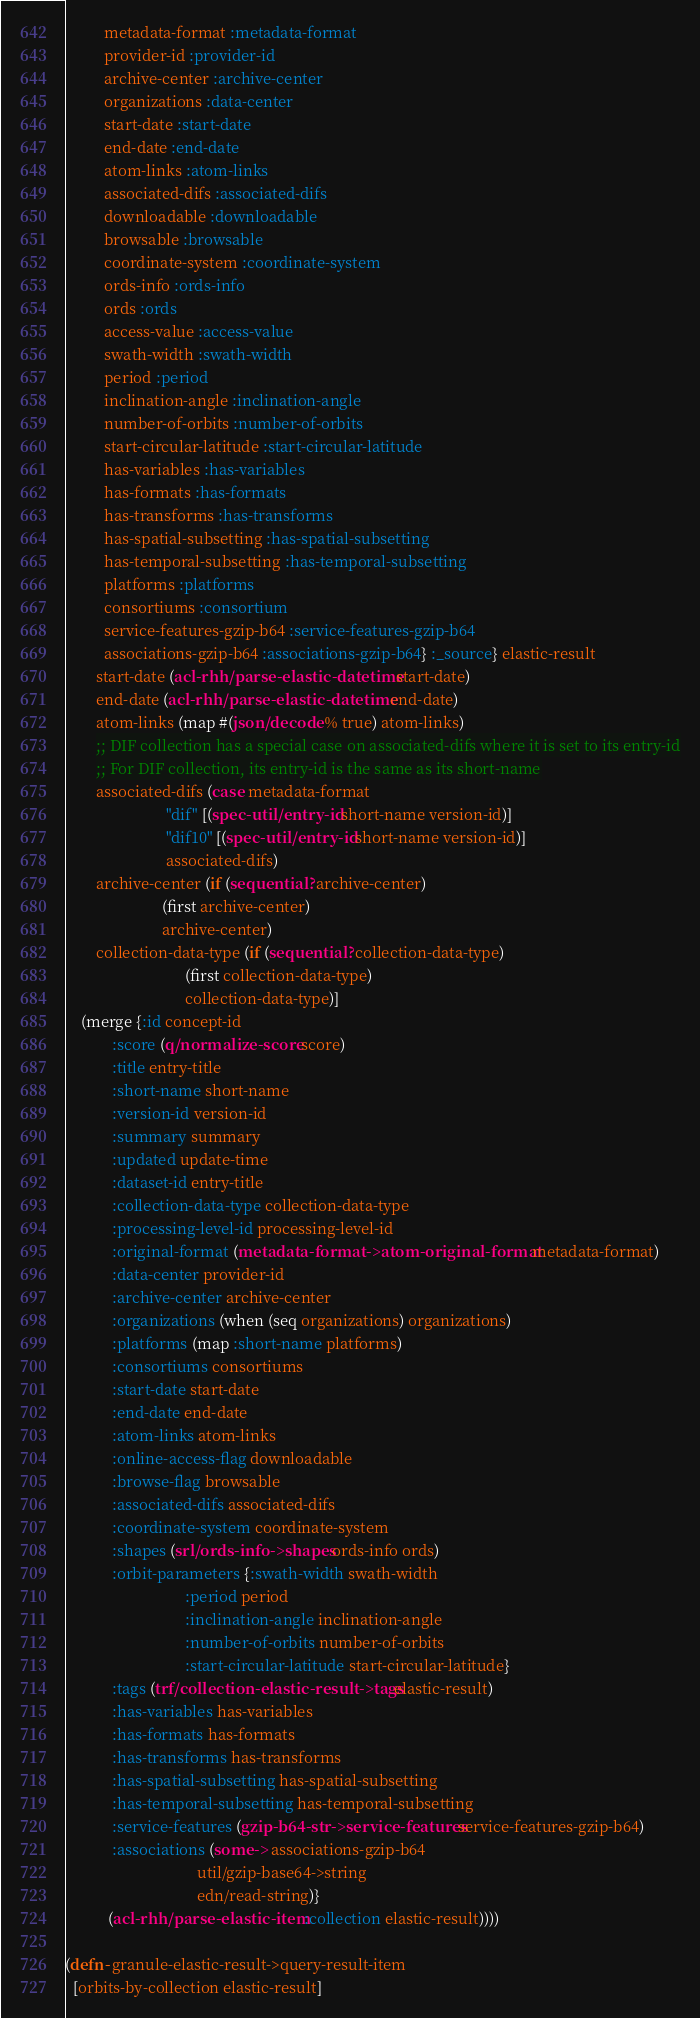Convert code to text. <code><loc_0><loc_0><loc_500><loc_500><_Clojure_>          metadata-format :metadata-format
          provider-id :provider-id
          archive-center :archive-center
          organizations :data-center
          start-date :start-date
          end-date :end-date
          atom-links :atom-links
          associated-difs :associated-difs
          downloadable :downloadable
          browsable :browsable
          coordinate-system :coordinate-system
          ords-info :ords-info
          ords :ords
          access-value :access-value
          swath-width :swath-width
          period :period
          inclination-angle :inclination-angle
          number-of-orbits :number-of-orbits
          start-circular-latitude :start-circular-latitude
          has-variables :has-variables
          has-formats :has-formats
          has-transforms :has-transforms
          has-spatial-subsetting :has-spatial-subsetting
          has-temporal-subsetting :has-temporal-subsetting
          platforms :platforms
          consortiums :consortium
          service-features-gzip-b64 :service-features-gzip-b64
          associations-gzip-b64 :associations-gzip-b64} :_source} elastic-result
        start-date (acl-rhh/parse-elastic-datetime start-date)
        end-date (acl-rhh/parse-elastic-datetime end-date)
        atom-links (map #(json/decode % true) atom-links)
        ;; DIF collection has a special case on associated-difs where it is set to its entry-id
        ;; For DIF collection, its entry-id is the same as its short-name
        associated-difs (case metadata-format
                          "dif" [(spec-util/entry-id short-name version-id)]
                          "dif10" [(spec-util/entry-id short-name version-id)]
                          associated-difs)
        archive-center (if (sequential? archive-center)
                         (first archive-center)
                         archive-center)
        collection-data-type (if (sequential? collection-data-type)
                               (first collection-data-type)
                               collection-data-type)]
    (merge {:id concept-id
            :score (q/normalize-score score)
            :title entry-title
            :short-name short-name
            :version-id version-id
            :summary summary
            :updated update-time
            :dataset-id entry-title
            :collection-data-type collection-data-type
            :processing-level-id processing-level-id
            :original-format (metadata-format->atom-original-format metadata-format)
            :data-center provider-id
            :archive-center archive-center
            :organizations (when (seq organizations) organizations)
            :platforms (map :short-name platforms)
            :consortiums consortiums
            :start-date start-date
            :end-date end-date
            :atom-links atom-links
            :online-access-flag downloadable
            :browse-flag browsable
            :associated-difs associated-difs
            :coordinate-system coordinate-system
            :shapes (srl/ords-info->shapes ords-info ords)
            :orbit-parameters {:swath-width swath-width
                               :period period
                               :inclination-angle inclination-angle
                               :number-of-orbits number-of-orbits
                               :start-circular-latitude start-circular-latitude}
            :tags (trf/collection-elastic-result->tags elastic-result)
            :has-variables has-variables
            :has-formats has-formats
            :has-transforms has-transforms
            :has-spatial-subsetting has-spatial-subsetting
            :has-temporal-subsetting has-temporal-subsetting
            :service-features (gzip-b64-str->service-features service-features-gzip-b64)
            :associations (some-> associations-gzip-b64
                                  util/gzip-base64->string
                                  edn/read-string)}
           (acl-rhh/parse-elastic-item :collection elastic-result))))

(defn- granule-elastic-result->query-result-item
  [orbits-by-collection elastic-result]</code> 